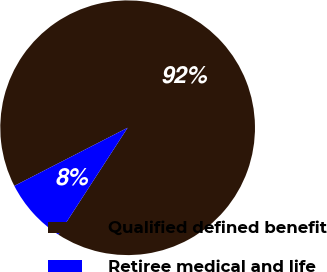Convert chart. <chart><loc_0><loc_0><loc_500><loc_500><pie_chart><fcel>Qualified defined benefit<fcel>Retiree medical and life<nl><fcel>91.7%<fcel>8.3%<nl></chart> 